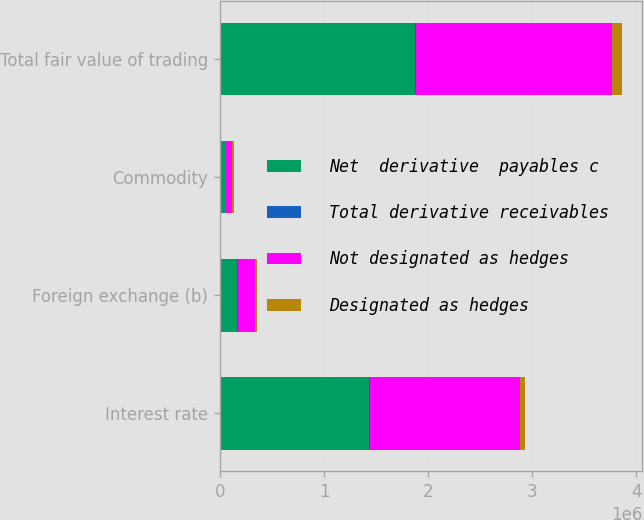Convert chart. <chart><loc_0><loc_0><loc_500><loc_500><stacked_bar_chart><ecel><fcel>Interest rate<fcel>Foreign exchange (b)<fcel>Commodity<fcel>Total fair value of trading<nl><fcel>Net  derivative  payables c<fcel>1.4339e+06<fcel>163497<fcel>53894<fcel>1.86868e+06<nl><fcel>Total derivative receivables<fcel>7621<fcel>4666<fcel>3535<fcel>15822<nl><fcel>Not designated as hedges<fcel>1.44152e+06<fcel>168163<fcel>57429<fcel>1.8845e+06<nl><fcel>Designated as hedges<fcel>46369<fcel>17890<fcel>14741<fcel>92477<nl></chart> 